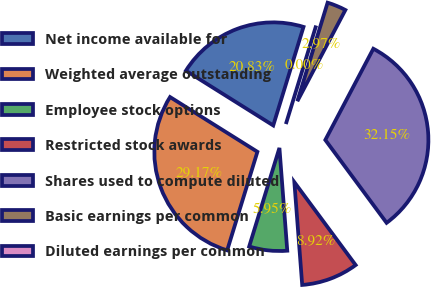<chart> <loc_0><loc_0><loc_500><loc_500><pie_chart><fcel>Net income available for<fcel>Weighted average outstanding<fcel>Employee stock options<fcel>Restricted stock awards<fcel>Shares used to compute diluted<fcel>Basic earnings per common<fcel>Diluted earnings per common<nl><fcel>20.83%<fcel>29.17%<fcel>5.95%<fcel>8.92%<fcel>32.15%<fcel>2.97%<fcel>0.0%<nl></chart> 